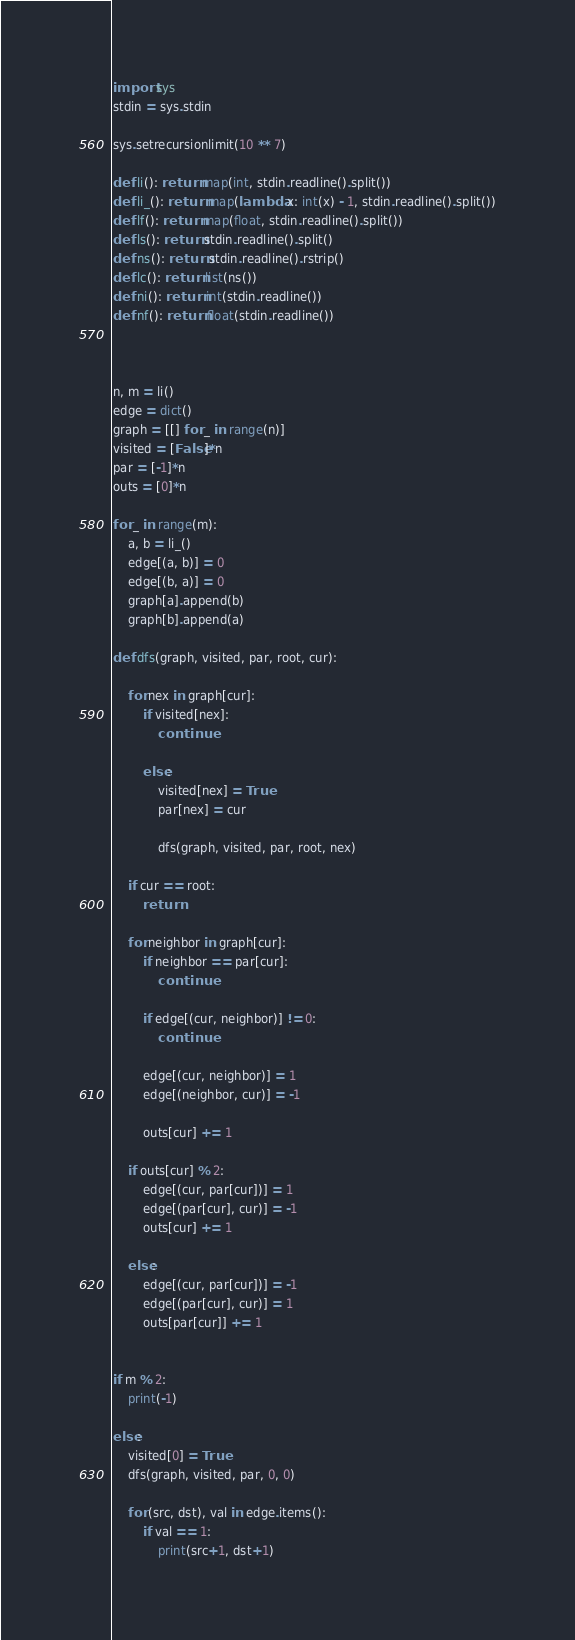Convert code to text. <code><loc_0><loc_0><loc_500><loc_500><_Python_>import sys
stdin = sys.stdin

sys.setrecursionlimit(10 ** 7)

def li(): return map(int, stdin.readline().split())
def li_(): return map(lambda x: int(x) - 1, stdin.readline().split())
def lf(): return map(float, stdin.readline().split())
def ls(): return stdin.readline().split()
def ns(): return stdin.readline().rstrip()
def lc(): return list(ns())
def ni(): return int(stdin.readline())
def nf(): return float(stdin.readline())



n, m = li()
edge = dict()
graph = [[] for _ in range(n)]
visited = [False]*n
par = [-1]*n
outs = [0]*n

for _ in range(m):
    a, b = li_()
    edge[(a, b)] = 0
    edge[(b, a)] = 0
    graph[a].append(b)
    graph[b].append(a)

def dfs(graph, visited, par, root, cur):

    for nex in graph[cur]:
        if visited[nex]:
            continue

        else:
            visited[nex] = True
            par[nex] = cur

            dfs(graph, visited, par, root, nex)

    if cur == root:
        return

    for neighbor in graph[cur]:
        if neighbor == par[cur]:
            continue

        if edge[(cur, neighbor)] != 0:
            continue

        edge[(cur, neighbor)] = 1
        edge[(neighbor, cur)] = -1

        outs[cur] += 1

    if outs[cur] % 2:
        edge[(cur, par[cur])] = 1
        edge[(par[cur], cur)] = -1
        outs[cur] += 1

    else:
        edge[(cur, par[cur])] = -1
        edge[(par[cur], cur)] = 1
        outs[par[cur]] += 1


if m % 2:
    print(-1)

else:
    visited[0] = True
    dfs(graph, visited, par, 0, 0)

    for (src, dst), val in edge.items():
        if val == 1:
            print(src+1, dst+1)
</code> 